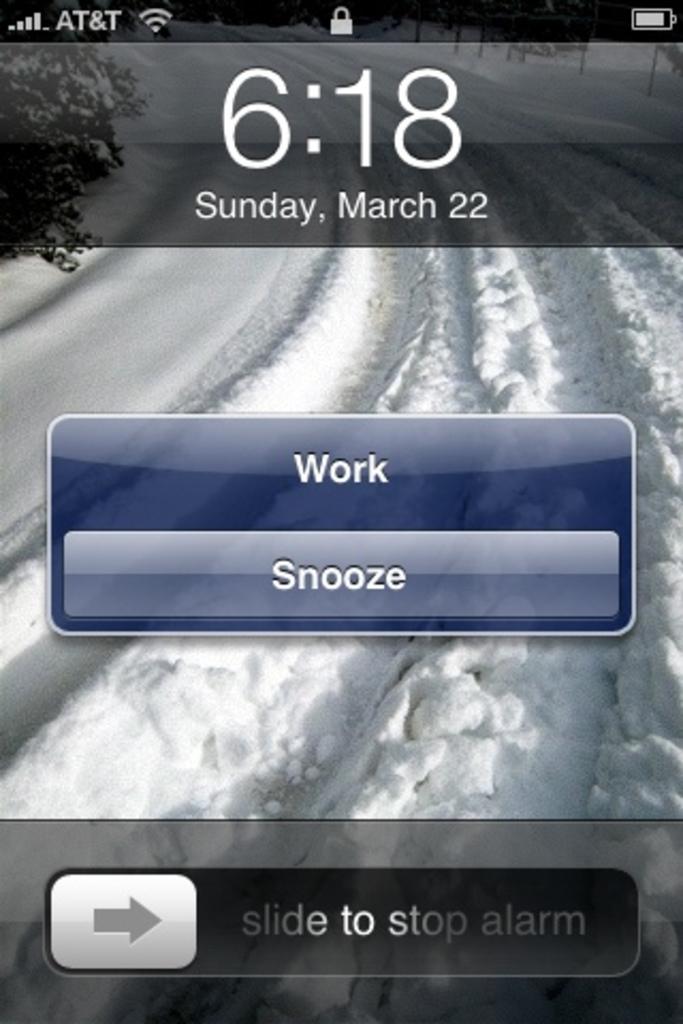What day of the week is indicated on this device?
Your answer should be compact. Sunday. Can you snooze the alarm?
Keep it short and to the point. Yes. 